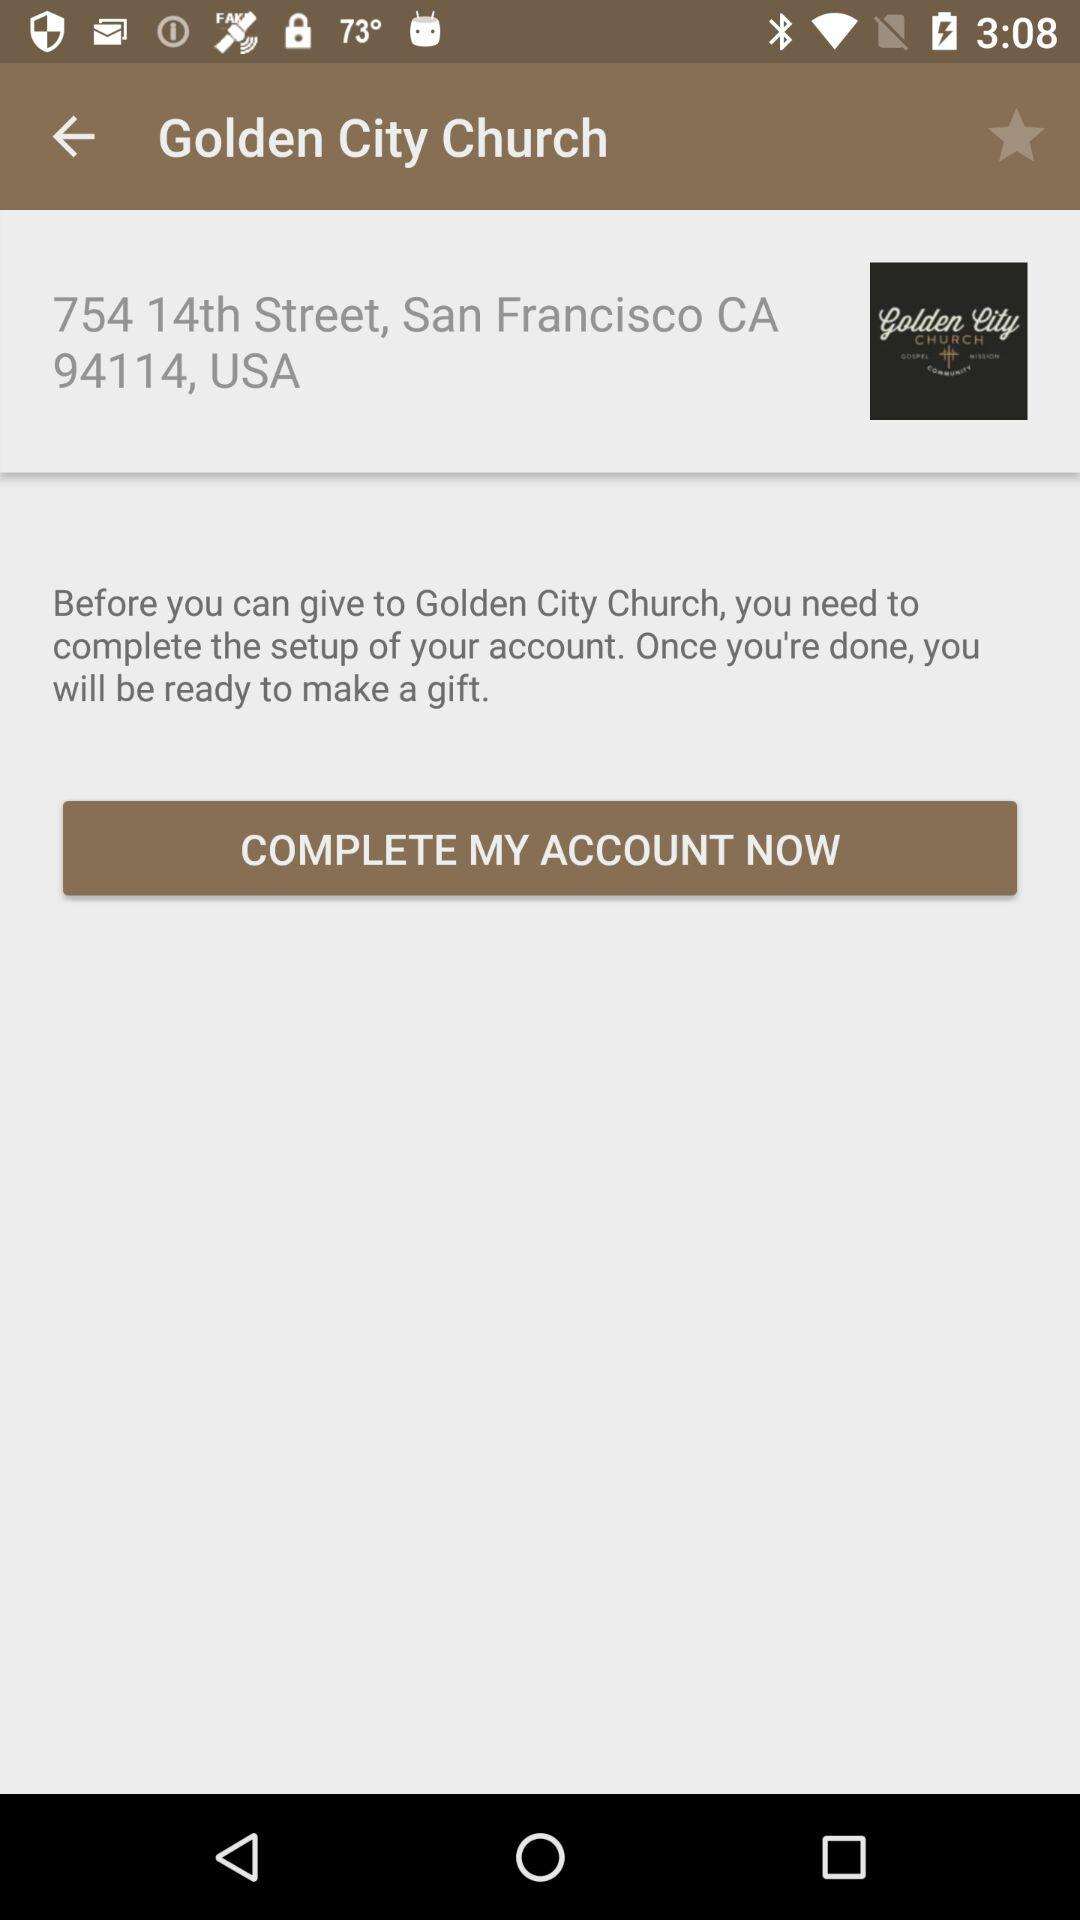What is the name of the church? The name of the church is "Golden City Church". 